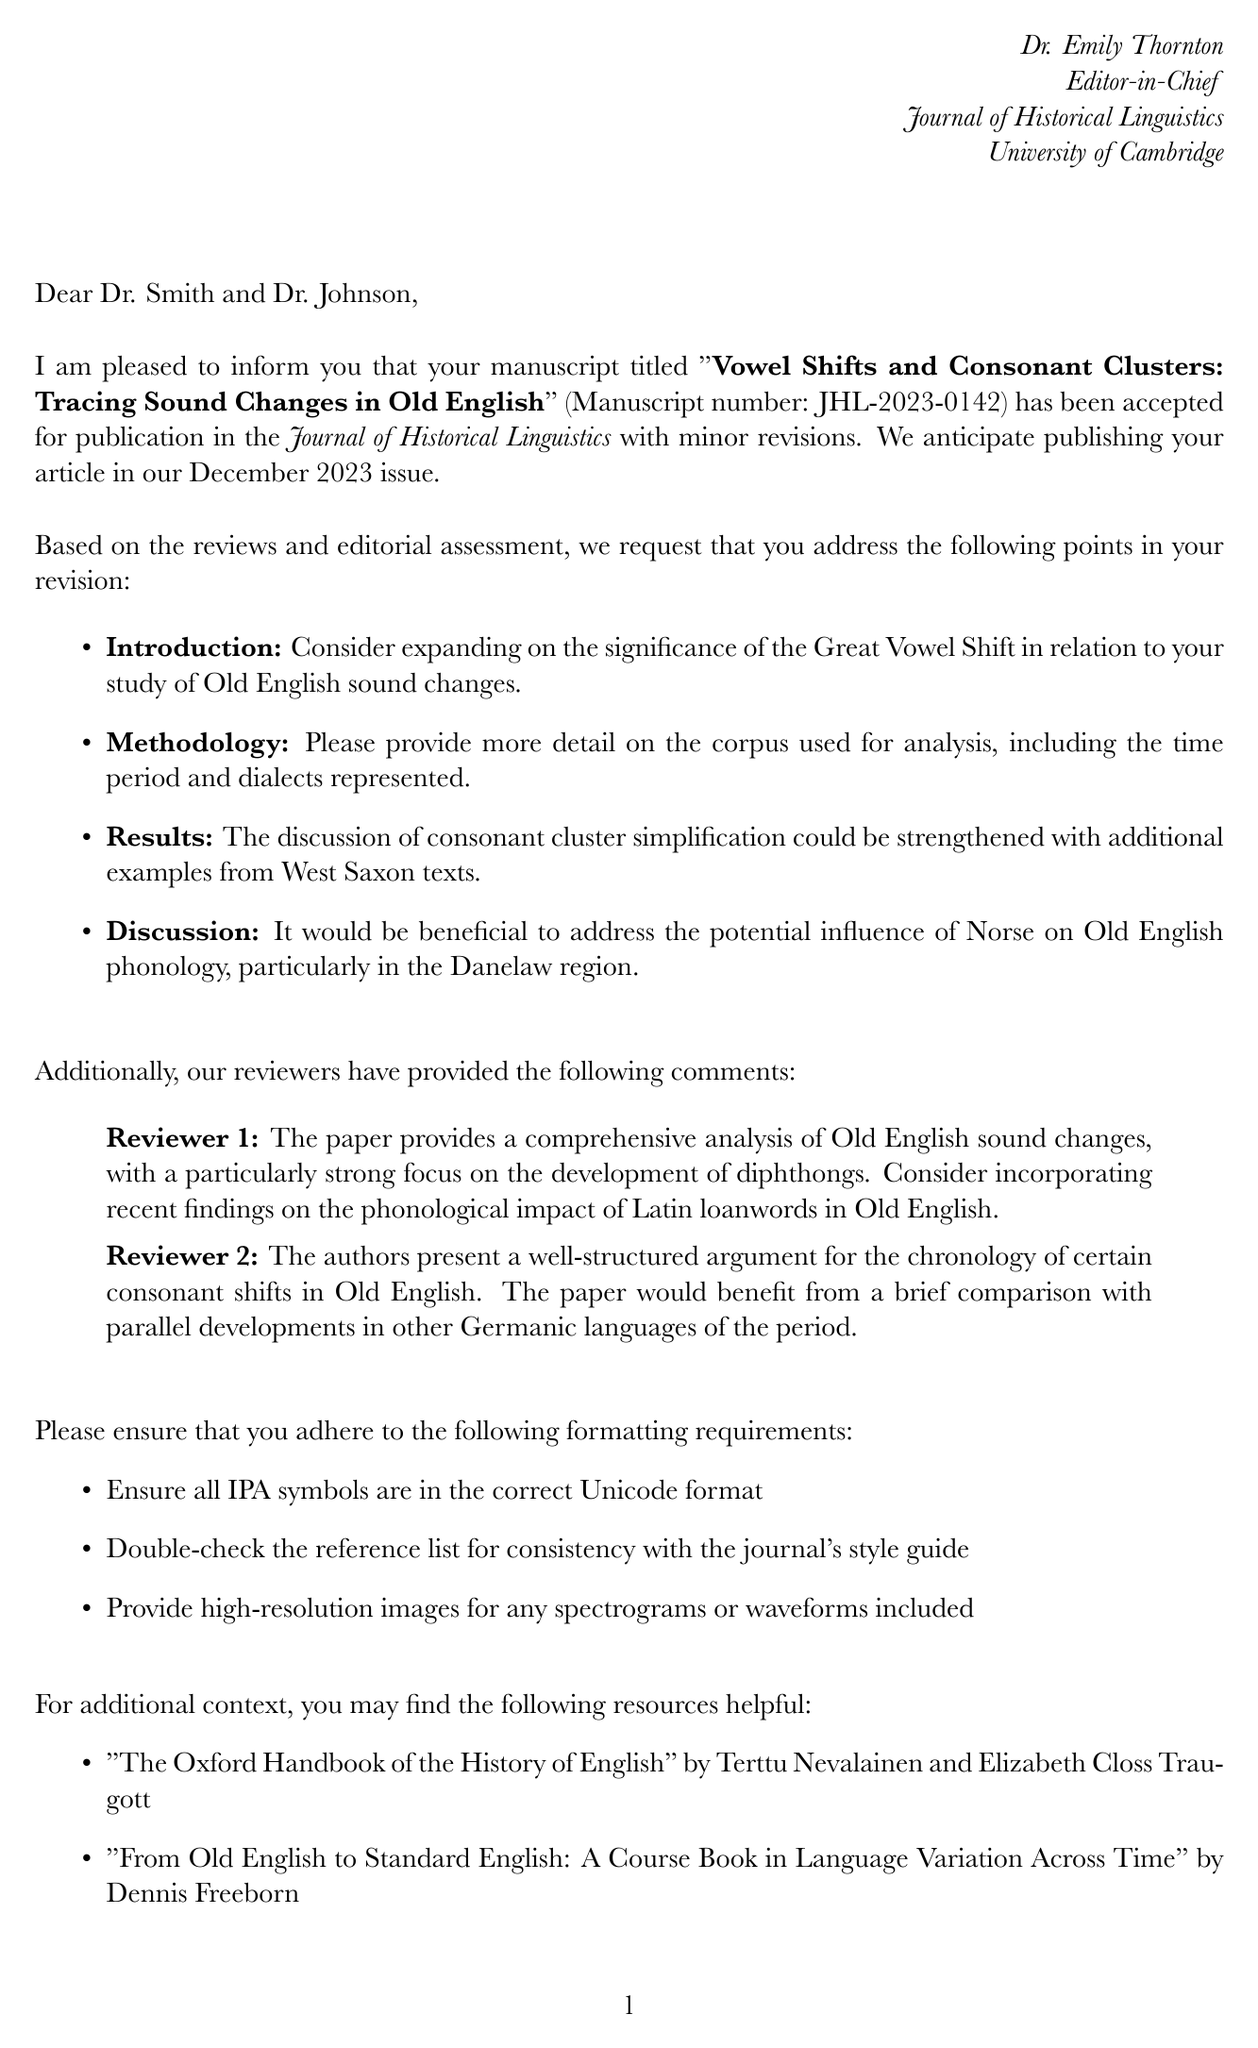What is the title of the paper? The title of the paper is mentioned in the letter as the focus of the acceptance, namely "Vowel Shifts and Consonant Clusters: Tracing Sound Changes in Old English."
Answer: Vowel Shifts and Consonant Clusters: Tracing Sound Changes in Old English Who are the authors of the paper? The authors of the paper are listed in the letter, indicating who conducted the research presented.
Answer: Jane Smith, Michael Johnson What is the decision made on the manuscript? The letter explicitly states the decision regarding the manuscript's publication status, which is a crucial aspect.
Answer: Accept with minor revisions What is the expected publication date of the paper? The letter provides a specific timeline for publication, which is relevant for the authors.
Answer: December 2023 issue What is one of the revision suggestions for the Introduction section? The letter details specific feedback for the authors, particularly suggesting improvements in certain sections.
Answer: Consider expanding on the significance of the Great Vowel Shift What is one of the requirements regarding IPA symbols? The letter lists formatting requirements that the authors need to comply with for their manuscript submission.
Answer: Ensure all IPA symbols are in the correct Unicode format How many reviewers provided comments? The letter mentions the involvement of reviewers in the assessment process of the manuscript, indicating the level of scrutiny.
Answer: 2 What is the deadline for submitting the revised manuscript? The letter specifies a final date by which the authors must submit their revisions, which is a critical date for their work.
Answer: June 30, 2023 What journal is the manuscript accepted for? The letter identifies the journal to which the manuscript has been accepted for publication, which is significant for the authors and their academic contributions.
Answer: Journal of Historical Linguistics 